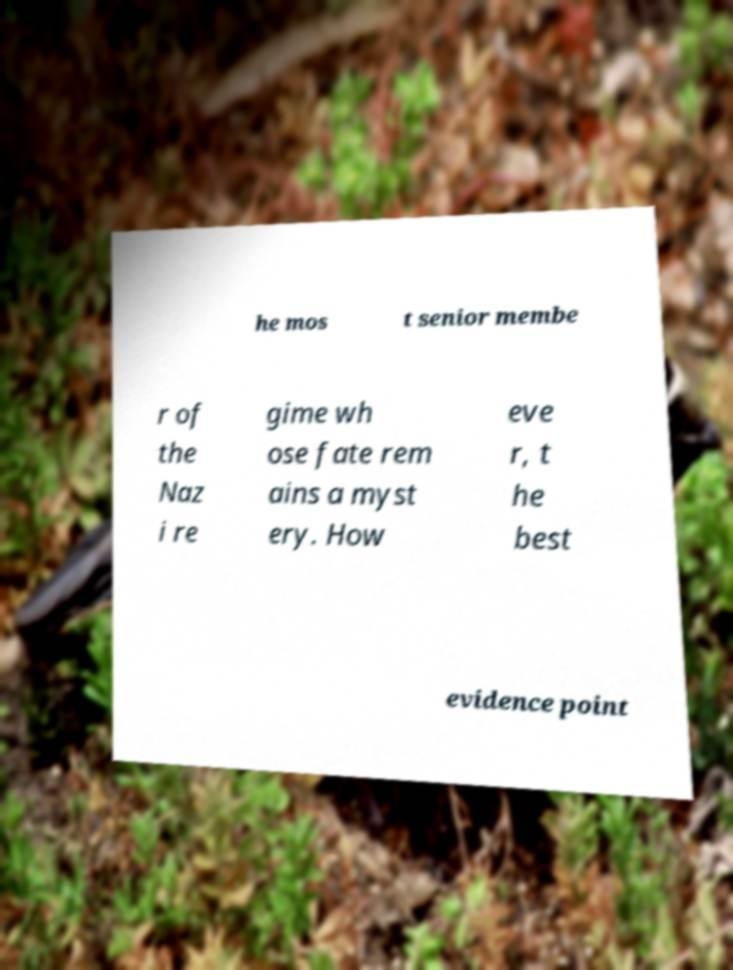What messages or text are displayed in this image? I need them in a readable, typed format. he mos t senior membe r of the Naz i re gime wh ose fate rem ains a myst ery. How eve r, t he best evidence point 